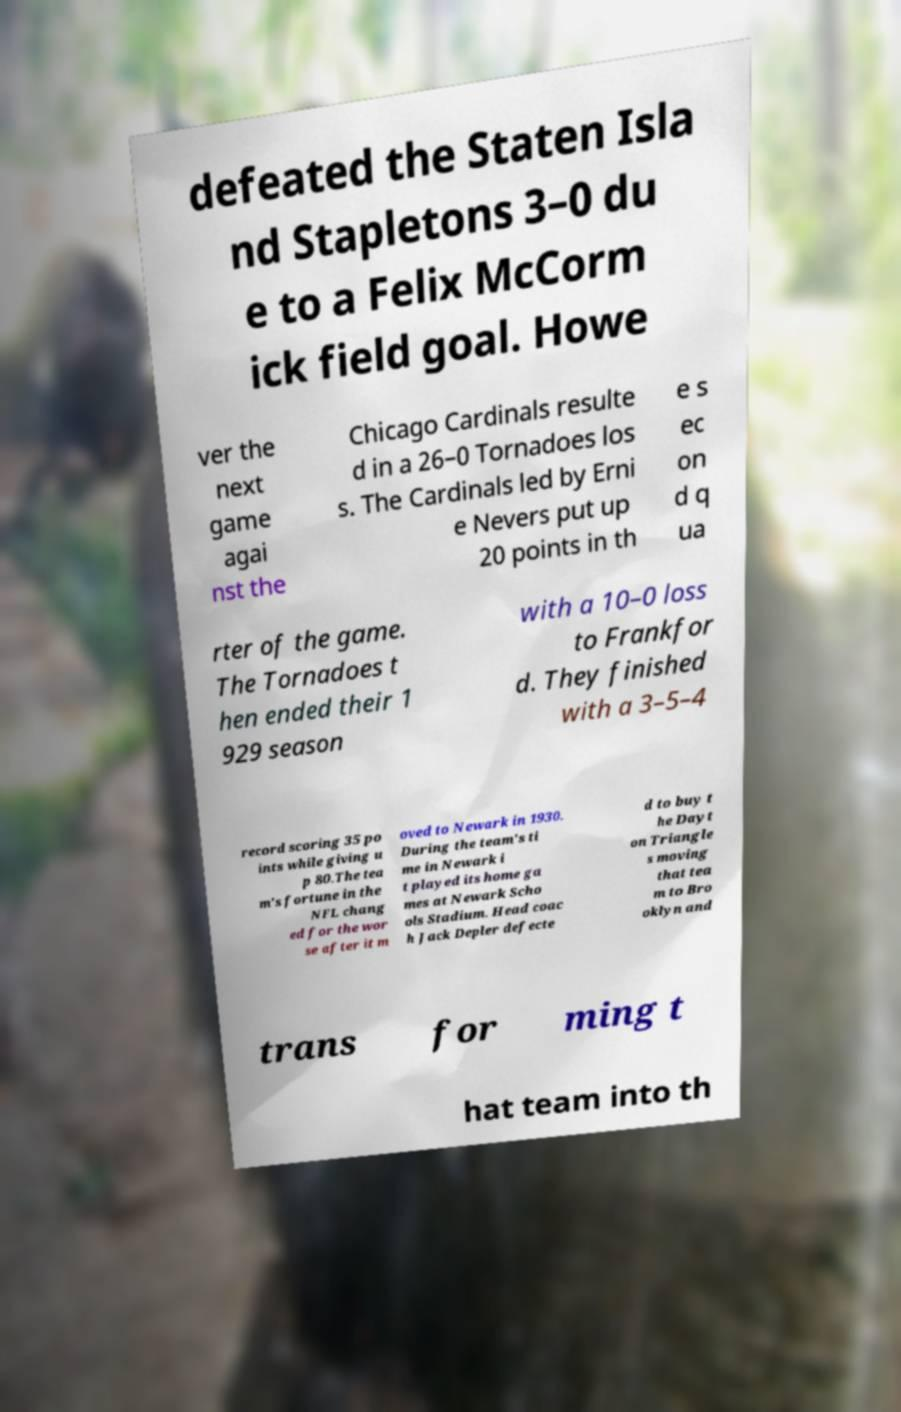I need the written content from this picture converted into text. Can you do that? defeated the Staten Isla nd Stapletons 3–0 du e to a Felix McCorm ick field goal. Howe ver the next game agai nst the Chicago Cardinals resulte d in a 26–0 Tornadoes los s. The Cardinals led by Erni e Nevers put up 20 points in th e s ec on d q ua rter of the game. The Tornadoes t hen ended their 1 929 season with a 10–0 loss to Frankfor d. They finished with a 3–5–4 record scoring 35 po ints while giving u p 80.The tea m's fortune in the NFL chang ed for the wor se after it m oved to Newark in 1930. During the team's ti me in Newark i t played its home ga mes at Newark Scho ols Stadium. Head coac h Jack Depler defecte d to buy t he Dayt on Triangle s moving that tea m to Bro oklyn and trans for ming t hat team into th 